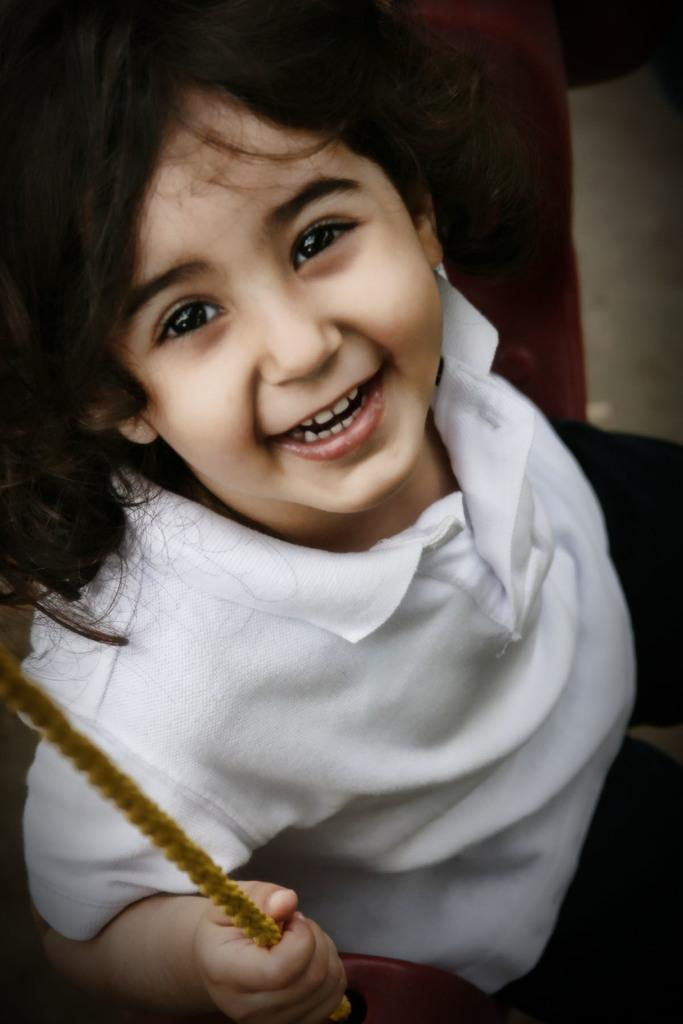Who is the main subject in the image? There is a girl in the image. What is the girl wearing? The girl is wearing a white T-shirt and black pants. What is the girl holding in her hand? The girl is holding a rope in her hand. What activity is the girl engaged in? The girl appears to be sitting on a swing. What type of prison can be seen in the background of the image? There is no prison present in the image; it features a girl sitting on a swing. How does the girl's attire change throughout the day in the image? The image is a still photograph, so the girl's attire does not change throughout the day. 